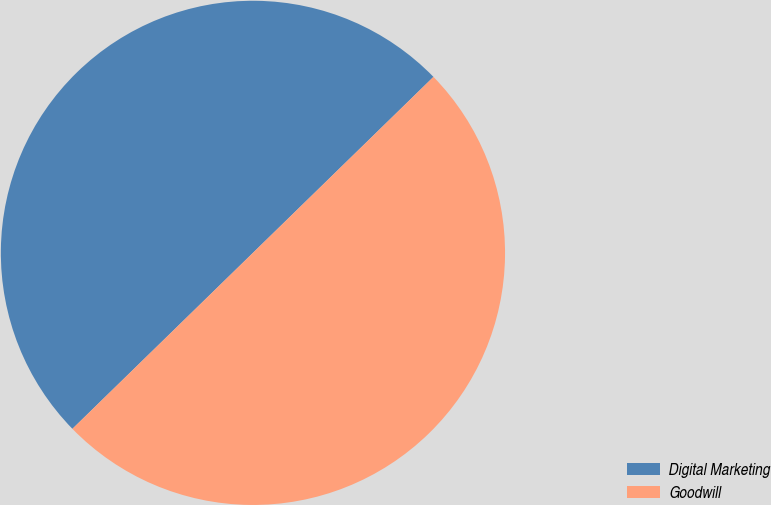Convert chart to OTSL. <chart><loc_0><loc_0><loc_500><loc_500><pie_chart><fcel>Digital Marketing<fcel>Goodwill<nl><fcel>50.0%<fcel>50.0%<nl></chart> 